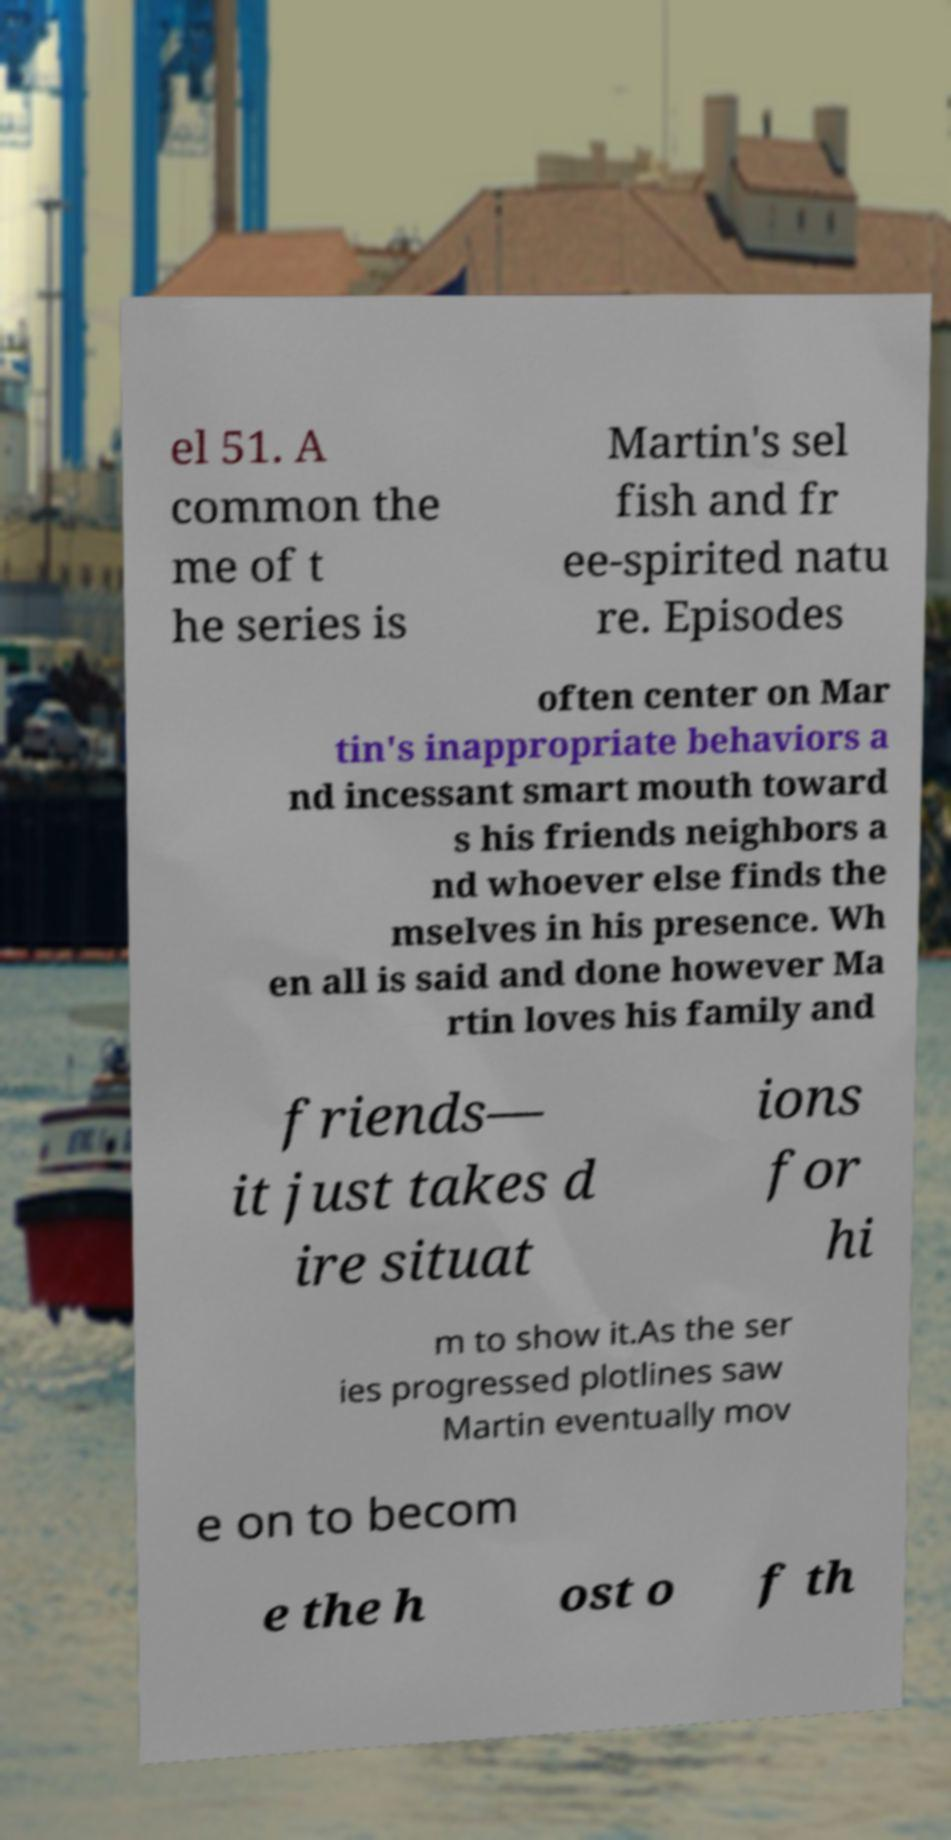Can you accurately transcribe the text from the provided image for me? el 51. A common the me of t he series is Martin's sel fish and fr ee-spirited natu re. Episodes often center on Mar tin's inappropriate behaviors a nd incessant smart mouth toward s his friends neighbors a nd whoever else finds the mselves in his presence. Wh en all is said and done however Ma rtin loves his family and friends— it just takes d ire situat ions for hi m to show it.As the ser ies progressed plotlines saw Martin eventually mov e on to becom e the h ost o f th 